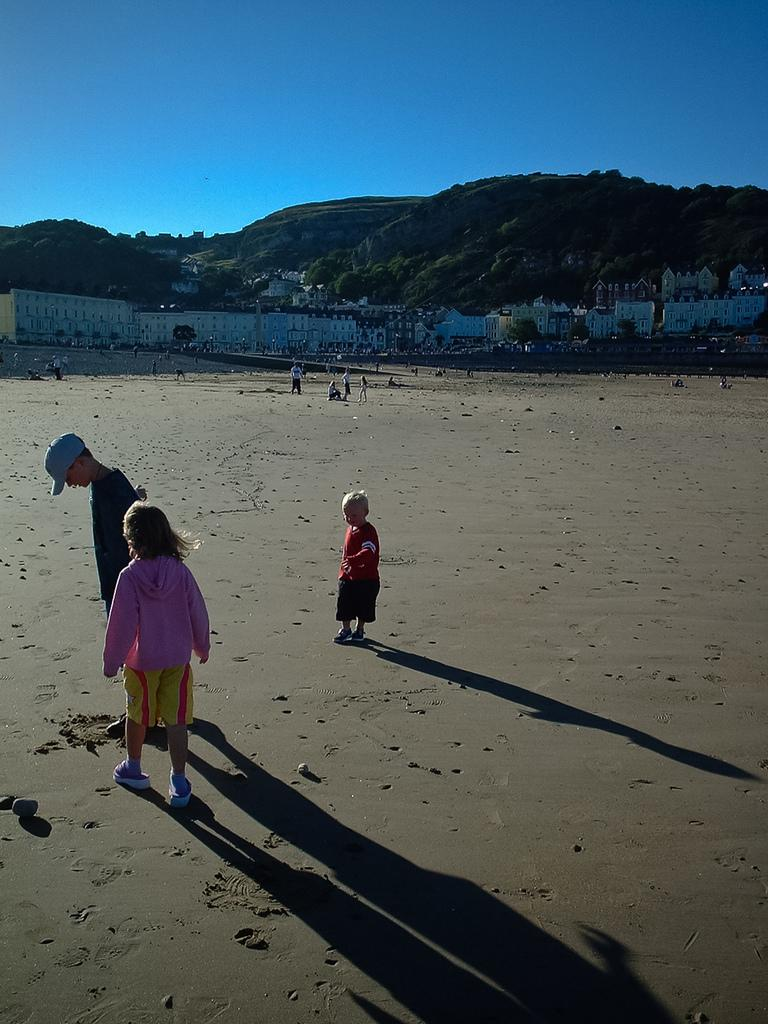What are the people in the image doing? The people in the image are standing on a path. What can be seen in the distance behind the people? Buildings, trees, hills, and the sky are visible in the background of the image. Can you describe the setting of the image? The image shows people standing on a path with a background that includes buildings, trees, hills, and the sky. What type of badge is the person wearing in the image? There is no person wearing a badge in the image. How does the window in the image affect the lighting? There is no window present in the image. 